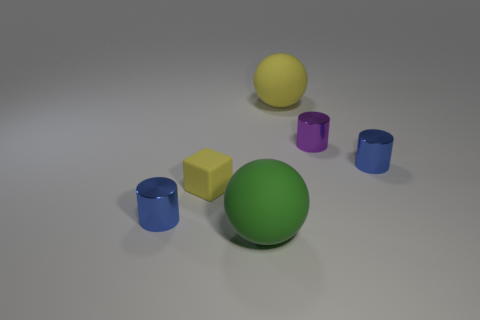Is the number of gray metallic things less than the number of big green things? yes 